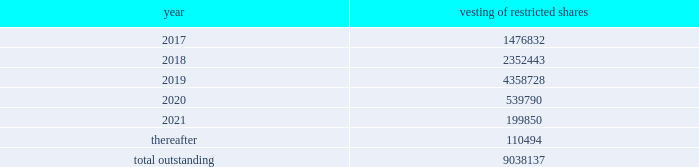The intrinsic value of restricted stock awards vested during the years ended december 31 , 2016 , 2015 and 2014 was $ 25 million , $ 31 million and $ 17 million , respectively .
Restricted stock awards made to employees have vesting periods ranging from 1 year with variable vesting dates to 10 years .
Following is a summary of the future vesting of our outstanding restricted stock awards : vesting of restricted shares .
The related compensation costs less estimated forfeitures is generally recognized ratably over the vesting period of the restricted stock awards .
Upon vesting , the grants will be paid in our class p common shares .
During 2016 , 2015 and 2014 , we recorded $ 66 million , $ 52 million and $ 51 million , respectively , in expense related to restricted stock awards and capitalized approximately $ 9 million , $ 15 million and $ 6 million , respectively .
At december 31 , 2016 and 2015 , unrecognized restricted stock awards compensation costs , less estimated forfeitures , was approximately $ 133 million and $ 154 million , respectively .
Pension and other postretirement benefit plans savings plan we maintain a defined contribution plan covering eligible u.s .
Employees .
We contribute 5% ( 5 % ) of eligible compensation for most of the plan participants .
Certain plan participants 2019 contributions and company contributions are based on collective bargaining agreements .
The total expense for our savings plan was approximately $ 48 million , $ 46 million , and $ 42 million for the years ended december 31 , 2016 , 2015 and 2014 , respectively .
Pension plans our u.s .
Pension plan is a defined benefit plan that covers substantially all of our u.s .
Employees and provides benefits under a cash balance formula .
A participant in the cash balance plan accrues benefits through contribution credits based on a combination of age and years of service , times eligible compensation .
Interest is also credited to the participant 2019s plan account .
A participant becomes fully vested in the plan after three years , and may take a lump sum distribution upon termination of employment or retirement .
Certain collectively bargained and grandfathered employees continue to accrue benefits through career pay or final pay formulas .
Two of our subsidiaries , kinder morgan canada inc .
And trans mountain pipeline inc .
( as general partner of trans mountain pipeline l.p. ) , are sponsors of pension plans for eligible canadian and trans mountain pipeline employees .
The plans include registered defined benefit pension plans , supplemental unfunded arrangements ( which provide pension benefits in excess of statutory limits ) and defined contributory plans .
Benefits under the defined benefit components accrue through career pay or final pay formulas .
The net periodic benefit costs , contributions and liability amounts associated with our canadian plans are not material to our consolidated income statements or balance sheets ; however , we began to include the activity and balances associated with our canadian plans ( including our canadian opeb plans discussed below ) in the following disclosures on a prospective basis beginning in 2016 .
The associated net periodic benefit costs for these combined canadian plans of $ 12 million and $ 10 million for the years ended december 31 , 2015 and 2014 , respectively , were reported separately in prior years .
Other postretirement benefit plans we and certain of our u.s .
Subsidiaries provide other postretirement benefits ( opeb ) , including medical benefits for closed groups of retired employees and certain grandfathered employees and their dependents , and limited postretirement life insurance benefits for retired employees .
Our canadian subsidiaries also provide opeb benefits to current and future retirees and their dependents .
Medical benefits under these opeb plans may be subject to deductibles , co-payment provisions , dollar .
What percentage of restricted shares is set to vest after 2021? 
Computations: (110494 / 9038137)
Answer: 0.01223. 